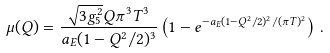<formula> <loc_0><loc_0><loc_500><loc_500>\mu ( Q ) = \frac { \sqrt { 3 g _ { 5 } ^ { 2 } } Q \pi ^ { 3 } T ^ { 3 } } { a _ { E } ( 1 - Q ^ { 2 } / 2 ) ^ { 3 } } \left ( 1 - e ^ { - a _ { E } ( 1 - Q ^ { 2 } / 2 ) ^ { 2 } / ( \pi T ) ^ { 2 } } \right ) \, .</formula> 